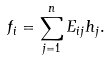Convert formula to latex. <formula><loc_0><loc_0><loc_500><loc_500>f _ { i } = \sum _ { j = 1 } ^ { n } E _ { i j } h _ { j } .</formula> 